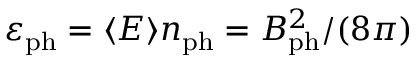<formula> <loc_0><loc_0><loc_500><loc_500>\varepsilon _ { p h } = \langle E \rangle n _ { p h } = B _ { p h } ^ { 2 } / ( 8 \pi )</formula> 